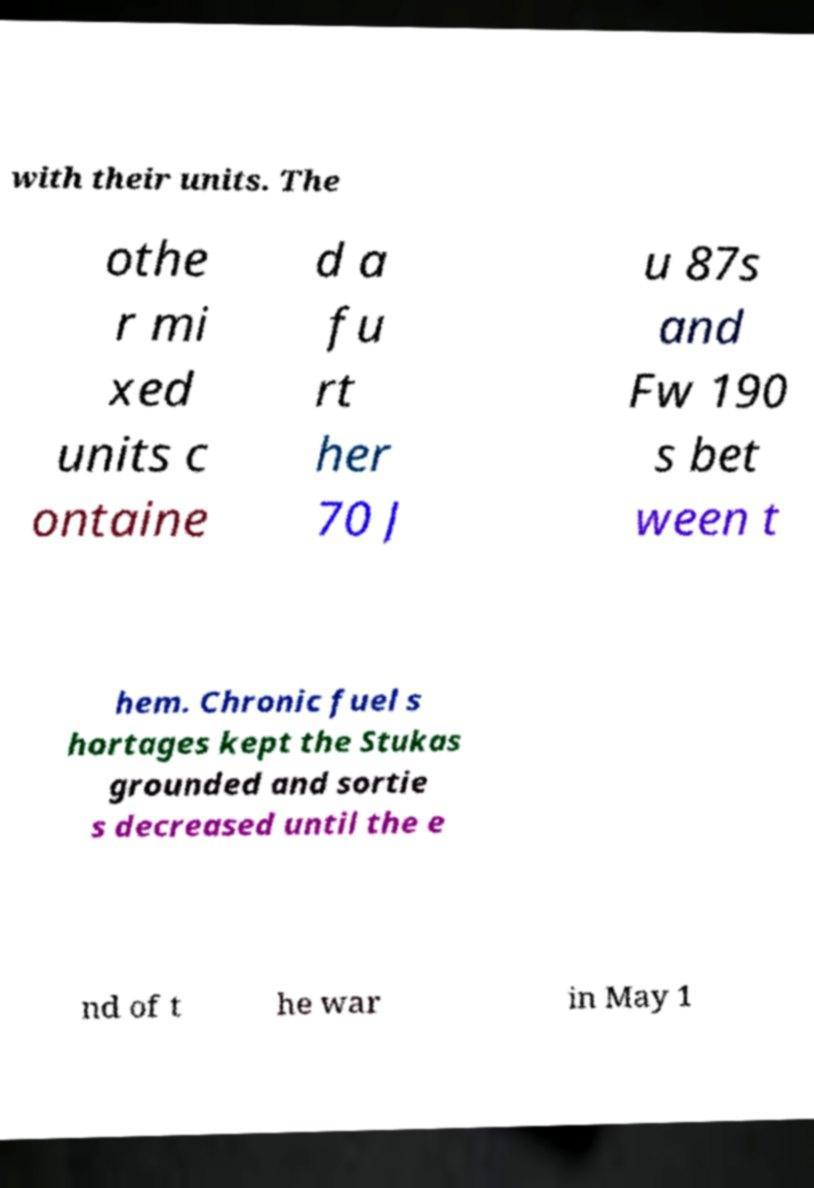I need the written content from this picture converted into text. Can you do that? with their units. The othe r mi xed units c ontaine d a fu rt her 70 J u 87s and Fw 190 s bet ween t hem. Chronic fuel s hortages kept the Stukas grounded and sortie s decreased until the e nd of t he war in May 1 